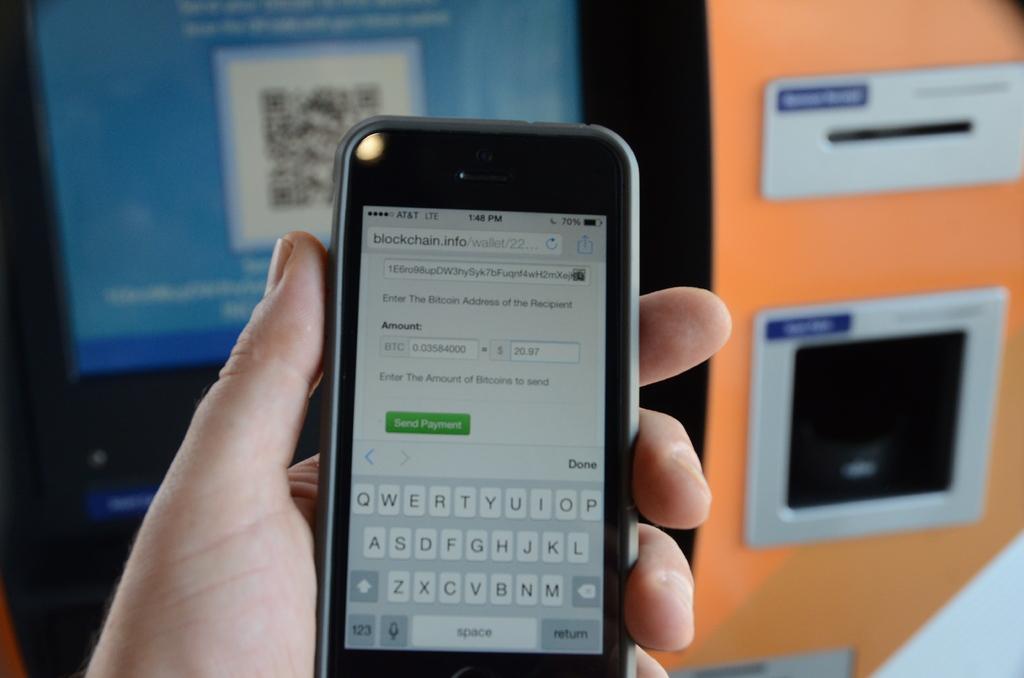What does the green button say?
Your response must be concise. Send payment. What is the first word in the address bar?
Your answer should be compact. Blockchain. 